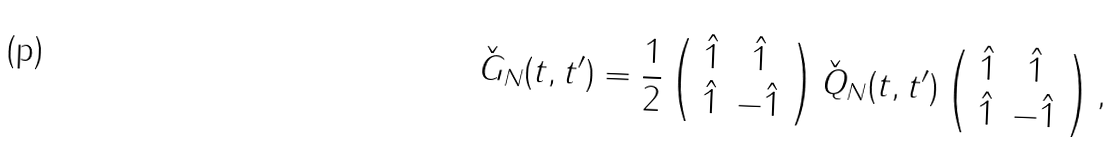<formula> <loc_0><loc_0><loc_500><loc_500>\check { G } _ { N } ( t , t ^ { \prime } ) = \frac { 1 } { 2 } \left ( \begin{array} { c c } \hat { 1 } & \hat { 1 } \\ \hat { 1 } & - \hat { 1 } \end{array} \right ) \check { Q } _ { N } ( t , t ^ { \prime } ) \left ( \begin{array} { c c } \hat { 1 } & \hat { 1 } \\ \hat { 1 } & - \hat { 1 } \end{array} \right ) ,</formula> 